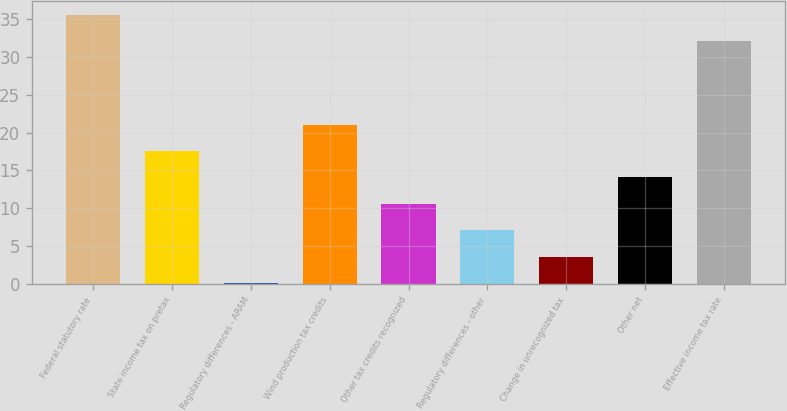Convert chart to OTSL. <chart><loc_0><loc_0><loc_500><loc_500><bar_chart><fcel>Federal statutory rate<fcel>State income tax on pretax<fcel>Regulatory differences - ARAM<fcel>Wind production tax credits<fcel>Other tax credits recognized<fcel>Regulatory differences - other<fcel>Change in unrecognized tax<fcel>Other net<fcel>Effective income tax rate<nl><fcel>35.59<fcel>17.55<fcel>0.1<fcel>21.04<fcel>10.57<fcel>7.08<fcel>3.59<fcel>14.06<fcel>32.1<nl></chart> 